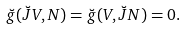<formula> <loc_0><loc_0><loc_500><loc_500>\breve { g } ( \breve { J } V , N ) = \breve { g } ( V , \breve { J } N ) = 0 .</formula> 